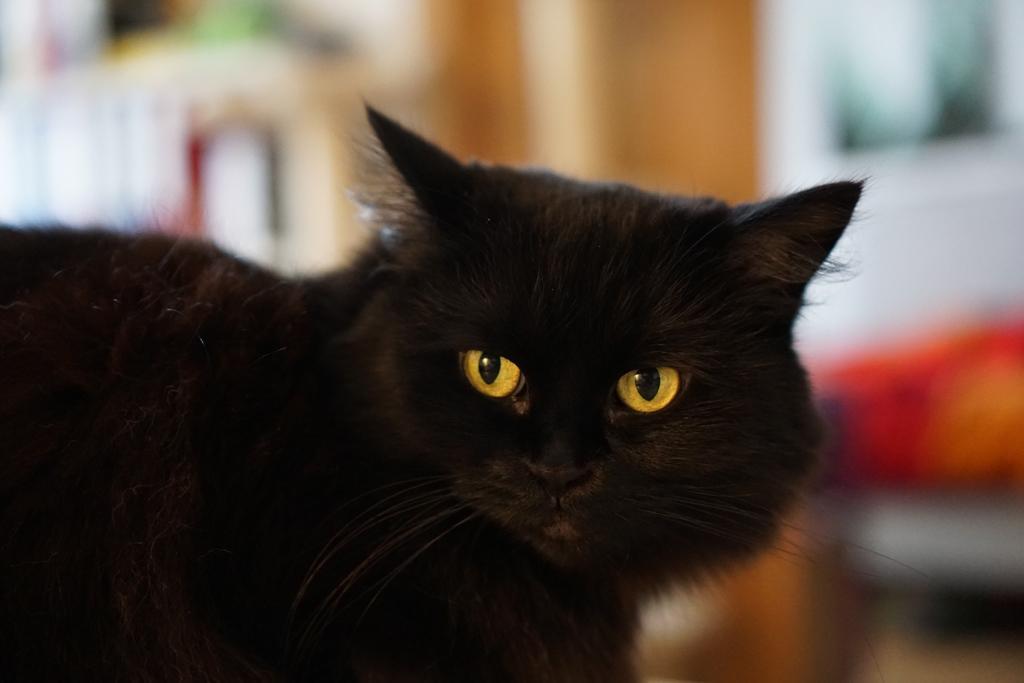Can you describe this image briefly? In this picture we can see black color cat and in the background image is blur. 